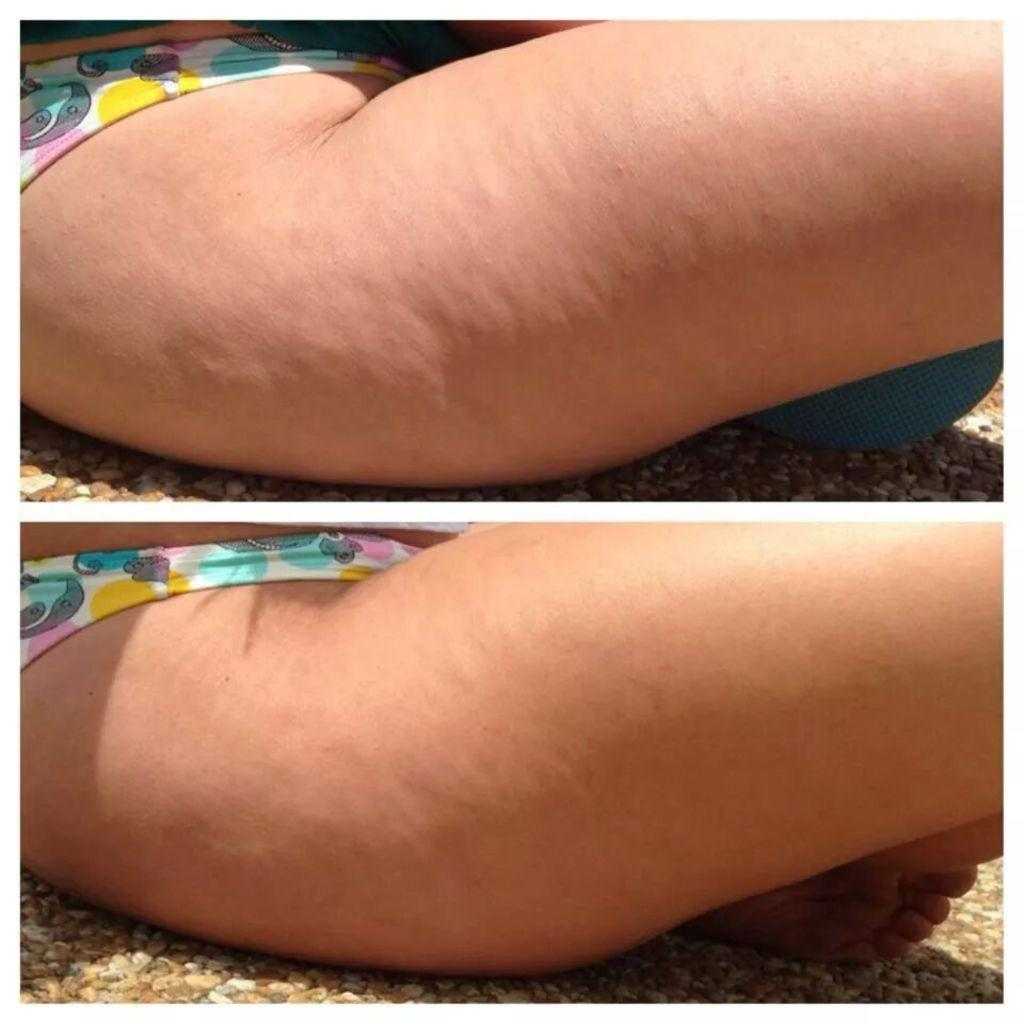What is the main subject of the image? The main subject of the image is a collage of photos. What can be seen in the photos? The photos contain images of people's legs. What is visible under the legs in the photos? There are stones visible under the legs in the photos. How many ladybugs can be seen crawling on the grandfather's leg in the image? There are no ladybugs or a grandfather present in the image; it contains a collage of photos with images of people's legs and stones visible under them. 